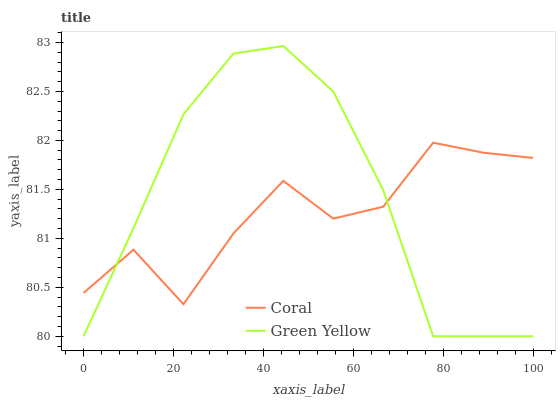Does Coral have the minimum area under the curve?
Answer yes or no. Yes. Does Green Yellow have the maximum area under the curve?
Answer yes or no. Yes. Does Green Yellow have the minimum area under the curve?
Answer yes or no. No. Is Green Yellow the smoothest?
Answer yes or no. Yes. Is Coral the roughest?
Answer yes or no. Yes. Is Green Yellow the roughest?
Answer yes or no. No. Does Green Yellow have the lowest value?
Answer yes or no. Yes. Does Green Yellow have the highest value?
Answer yes or no. Yes. Does Green Yellow intersect Coral?
Answer yes or no. Yes. Is Green Yellow less than Coral?
Answer yes or no. No. Is Green Yellow greater than Coral?
Answer yes or no. No. 